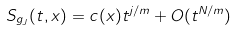Convert formula to latex. <formula><loc_0><loc_0><loc_500><loc_500>S _ { g _ { J } } ( t , x ) = c ( x ) t ^ { j / m } + O ( t ^ { N / m } )</formula> 